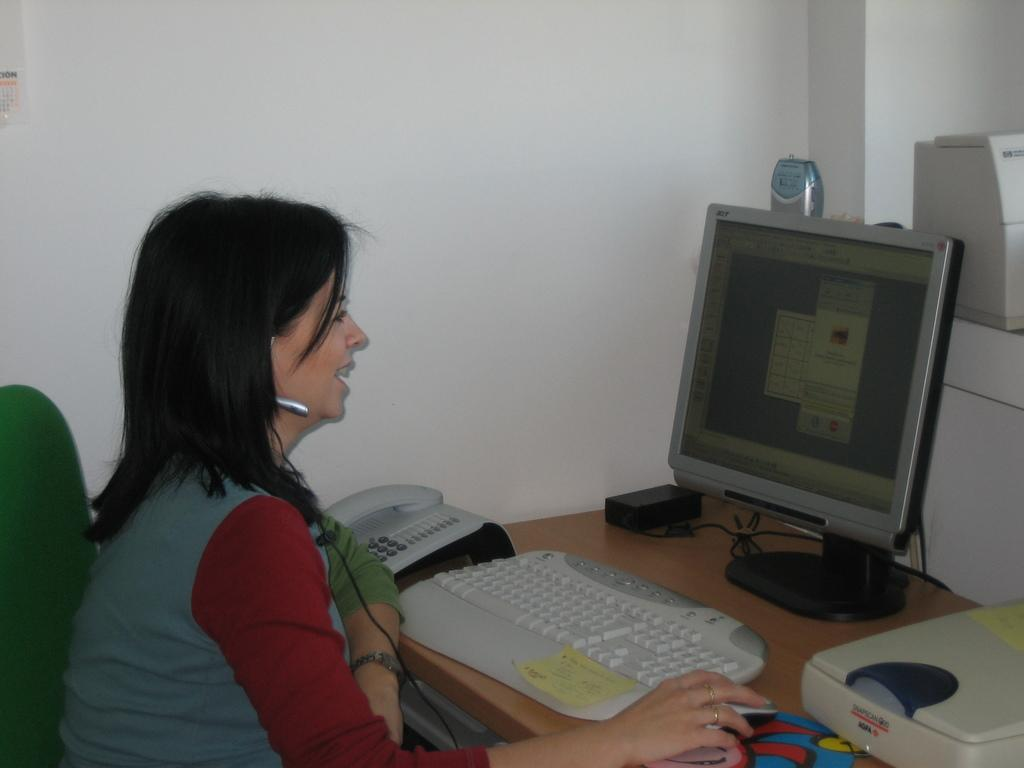What is the woman in the image doing? The woman is sitting on a chair in the image. What can be seen on the desk top in the image? There is a keyboard in the image. What device is present for communication purposes? There is a telephone in the image. What is visible in the background of the image? There is a table and a wall in the background of the image. Can you see the woman attempting to sail in the image? There is no indication of the woman attempting to sail in the image; she is sitting on a chair. 